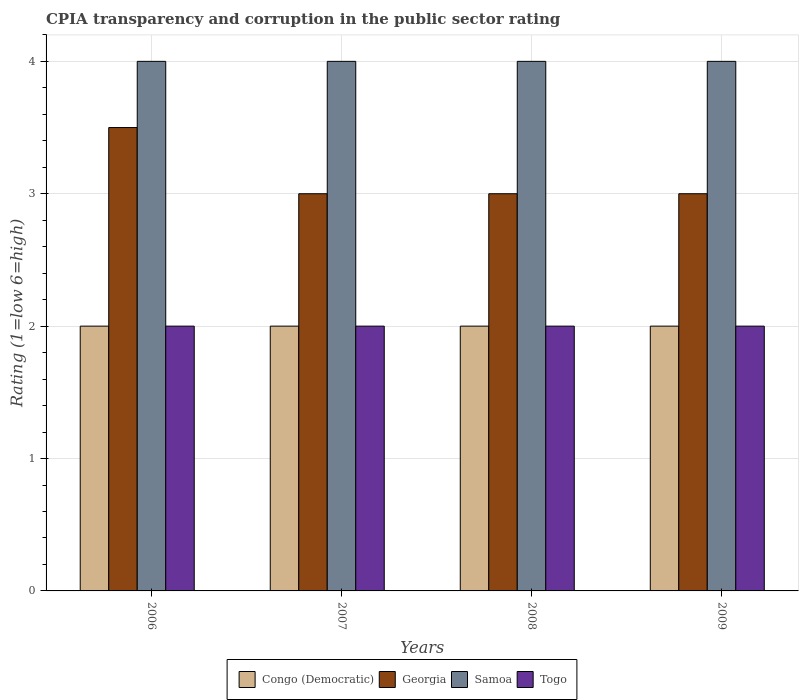How many different coloured bars are there?
Offer a terse response. 4. How many groups of bars are there?
Keep it short and to the point. 4. How many bars are there on the 1st tick from the right?
Your answer should be very brief. 4. What is the label of the 3rd group of bars from the left?
Make the answer very short. 2008. What is the CPIA rating in Congo (Democratic) in 2009?
Your response must be concise. 2. Across all years, what is the maximum CPIA rating in Georgia?
Give a very brief answer. 3.5. Across all years, what is the minimum CPIA rating in Togo?
Keep it short and to the point. 2. In the year 2006, what is the difference between the CPIA rating in Congo (Democratic) and CPIA rating in Samoa?
Give a very brief answer. -2. In how many years, is the CPIA rating in Georgia greater than 0.6000000000000001?
Your answer should be very brief. 4. What is the difference between the highest and the second highest CPIA rating in Congo (Democratic)?
Make the answer very short. 0. Is it the case that in every year, the sum of the CPIA rating in Samoa and CPIA rating in Georgia is greater than the sum of CPIA rating in Togo and CPIA rating in Congo (Democratic)?
Keep it short and to the point. No. What does the 3rd bar from the left in 2007 represents?
Give a very brief answer. Samoa. What does the 1st bar from the right in 2007 represents?
Offer a very short reply. Togo. How many bars are there?
Make the answer very short. 16. Are all the bars in the graph horizontal?
Your answer should be very brief. No. What is the difference between two consecutive major ticks on the Y-axis?
Provide a succinct answer. 1. Does the graph contain any zero values?
Give a very brief answer. No. Where does the legend appear in the graph?
Keep it short and to the point. Bottom center. How are the legend labels stacked?
Make the answer very short. Horizontal. What is the title of the graph?
Keep it short and to the point. CPIA transparency and corruption in the public sector rating. Does "Cameroon" appear as one of the legend labels in the graph?
Give a very brief answer. No. What is the label or title of the X-axis?
Give a very brief answer. Years. What is the Rating (1=low 6=high) of Congo (Democratic) in 2006?
Your answer should be compact. 2. What is the Rating (1=low 6=high) of Georgia in 2006?
Offer a terse response. 3.5. What is the Rating (1=low 6=high) in Samoa in 2006?
Provide a short and direct response. 4. What is the Rating (1=low 6=high) of Togo in 2006?
Provide a succinct answer. 2. What is the Rating (1=low 6=high) of Congo (Democratic) in 2007?
Your response must be concise. 2. What is the Rating (1=low 6=high) of Samoa in 2007?
Give a very brief answer. 4. What is the Rating (1=low 6=high) in Samoa in 2008?
Provide a succinct answer. 4. What is the Rating (1=low 6=high) of Georgia in 2009?
Keep it short and to the point. 3. What is the Rating (1=low 6=high) of Samoa in 2009?
Your answer should be very brief. 4. What is the Rating (1=low 6=high) of Togo in 2009?
Give a very brief answer. 2. Across all years, what is the maximum Rating (1=low 6=high) in Congo (Democratic)?
Your response must be concise. 2. Across all years, what is the maximum Rating (1=low 6=high) in Togo?
Offer a very short reply. 2. Across all years, what is the minimum Rating (1=low 6=high) of Congo (Democratic)?
Offer a terse response. 2. What is the total Rating (1=low 6=high) of Congo (Democratic) in the graph?
Give a very brief answer. 8. What is the total Rating (1=low 6=high) of Samoa in the graph?
Ensure brevity in your answer.  16. What is the difference between the Rating (1=low 6=high) of Congo (Democratic) in 2006 and that in 2007?
Your answer should be compact. 0. What is the difference between the Rating (1=low 6=high) in Congo (Democratic) in 2006 and that in 2008?
Ensure brevity in your answer.  0. What is the difference between the Rating (1=low 6=high) of Georgia in 2006 and that in 2008?
Make the answer very short. 0.5. What is the difference between the Rating (1=low 6=high) of Samoa in 2006 and that in 2008?
Keep it short and to the point. 0. What is the difference between the Rating (1=low 6=high) in Togo in 2006 and that in 2008?
Give a very brief answer. 0. What is the difference between the Rating (1=low 6=high) of Congo (Democratic) in 2007 and that in 2008?
Offer a terse response. 0. What is the difference between the Rating (1=low 6=high) in Samoa in 2007 and that in 2008?
Your response must be concise. 0. What is the difference between the Rating (1=low 6=high) in Togo in 2007 and that in 2008?
Your response must be concise. 0. What is the difference between the Rating (1=low 6=high) of Congo (Democratic) in 2007 and that in 2009?
Keep it short and to the point. 0. What is the difference between the Rating (1=low 6=high) of Georgia in 2008 and that in 2009?
Your answer should be compact. 0. What is the difference between the Rating (1=low 6=high) in Samoa in 2008 and that in 2009?
Offer a terse response. 0. What is the difference between the Rating (1=low 6=high) of Togo in 2008 and that in 2009?
Keep it short and to the point. 0. What is the difference between the Rating (1=low 6=high) of Samoa in 2006 and the Rating (1=low 6=high) of Togo in 2008?
Your response must be concise. 2. What is the difference between the Rating (1=low 6=high) in Congo (Democratic) in 2006 and the Rating (1=low 6=high) in Samoa in 2009?
Give a very brief answer. -2. What is the difference between the Rating (1=low 6=high) of Georgia in 2006 and the Rating (1=low 6=high) of Samoa in 2009?
Ensure brevity in your answer.  -0.5. What is the difference between the Rating (1=low 6=high) of Georgia in 2006 and the Rating (1=low 6=high) of Togo in 2009?
Provide a short and direct response. 1.5. What is the difference between the Rating (1=low 6=high) in Samoa in 2006 and the Rating (1=low 6=high) in Togo in 2009?
Provide a succinct answer. 2. What is the difference between the Rating (1=low 6=high) in Congo (Democratic) in 2007 and the Rating (1=low 6=high) in Togo in 2008?
Provide a succinct answer. 0. What is the difference between the Rating (1=low 6=high) in Congo (Democratic) in 2007 and the Rating (1=low 6=high) in Samoa in 2009?
Keep it short and to the point. -2. What is the difference between the Rating (1=low 6=high) in Congo (Democratic) in 2007 and the Rating (1=low 6=high) in Togo in 2009?
Offer a terse response. 0. What is the difference between the Rating (1=low 6=high) of Georgia in 2007 and the Rating (1=low 6=high) of Samoa in 2009?
Offer a terse response. -1. What is the difference between the Rating (1=low 6=high) in Samoa in 2007 and the Rating (1=low 6=high) in Togo in 2009?
Offer a terse response. 2. What is the difference between the Rating (1=low 6=high) of Congo (Democratic) in 2008 and the Rating (1=low 6=high) of Togo in 2009?
Offer a terse response. 0. What is the difference between the Rating (1=low 6=high) in Georgia in 2008 and the Rating (1=low 6=high) in Samoa in 2009?
Make the answer very short. -1. What is the average Rating (1=low 6=high) in Georgia per year?
Keep it short and to the point. 3.12. In the year 2006, what is the difference between the Rating (1=low 6=high) in Congo (Democratic) and Rating (1=low 6=high) in Georgia?
Provide a succinct answer. -1.5. In the year 2006, what is the difference between the Rating (1=low 6=high) of Congo (Democratic) and Rating (1=low 6=high) of Togo?
Your answer should be compact. 0. In the year 2006, what is the difference between the Rating (1=low 6=high) in Georgia and Rating (1=low 6=high) in Samoa?
Provide a short and direct response. -0.5. In the year 2006, what is the difference between the Rating (1=low 6=high) in Georgia and Rating (1=low 6=high) in Togo?
Provide a succinct answer. 1.5. In the year 2006, what is the difference between the Rating (1=low 6=high) of Samoa and Rating (1=low 6=high) of Togo?
Offer a terse response. 2. In the year 2007, what is the difference between the Rating (1=low 6=high) of Congo (Democratic) and Rating (1=low 6=high) of Georgia?
Your answer should be compact. -1. In the year 2007, what is the difference between the Rating (1=low 6=high) in Congo (Democratic) and Rating (1=low 6=high) in Samoa?
Ensure brevity in your answer.  -2. In the year 2007, what is the difference between the Rating (1=low 6=high) of Congo (Democratic) and Rating (1=low 6=high) of Togo?
Your answer should be very brief. 0. In the year 2007, what is the difference between the Rating (1=low 6=high) of Georgia and Rating (1=low 6=high) of Samoa?
Offer a very short reply. -1. In the year 2007, what is the difference between the Rating (1=low 6=high) of Samoa and Rating (1=low 6=high) of Togo?
Keep it short and to the point. 2. In the year 2008, what is the difference between the Rating (1=low 6=high) of Congo (Democratic) and Rating (1=low 6=high) of Samoa?
Your answer should be very brief. -2. In the year 2008, what is the difference between the Rating (1=low 6=high) of Congo (Democratic) and Rating (1=low 6=high) of Togo?
Make the answer very short. 0. In the year 2008, what is the difference between the Rating (1=low 6=high) of Georgia and Rating (1=low 6=high) of Samoa?
Offer a terse response. -1. In the year 2008, what is the difference between the Rating (1=low 6=high) of Georgia and Rating (1=low 6=high) of Togo?
Your answer should be compact. 1. In the year 2008, what is the difference between the Rating (1=low 6=high) of Samoa and Rating (1=low 6=high) of Togo?
Your answer should be very brief. 2. In the year 2009, what is the difference between the Rating (1=low 6=high) in Congo (Democratic) and Rating (1=low 6=high) in Samoa?
Provide a short and direct response. -2. In the year 2009, what is the difference between the Rating (1=low 6=high) of Congo (Democratic) and Rating (1=low 6=high) of Togo?
Your answer should be compact. 0. In the year 2009, what is the difference between the Rating (1=low 6=high) in Georgia and Rating (1=low 6=high) in Samoa?
Provide a succinct answer. -1. What is the ratio of the Rating (1=low 6=high) in Congo (Democratic) in 2006 to that in 2007?
Provide a succinct answer. 1. What is the ratio of the Rating (1=low 6=high) in Georgia in 2006 to that in 2007?
Offer a terse response. 1.17. What is the ratio of the Rating (1=low 6=high) in Samoa in 2006 to that in 2007?
Provide a succinct answer. 1. What is the ratio of the Rating (1=low 6=high) of Togo in 2006 to that in 2007?
Provide a short and direct response. 1. What is the ratio of the Rating (1=low 6=high) in Congo (Democratic) in 2006 to that in 2008?
Make the answer very short. 1. What is the ratio of the Rating (1=low 6=high) of Togo in 2006 to that in 2008?
Provide a short and direct response. 1. What is the ratio of the Rating (1=low 6=high) of Congo (Democratic) in 2006 to that in 2009?
Provide a succinct answer. 1. What is the ratio of the Rating (1=low 6=high) of Georgia in 2006 to that in 2009?
Offer a very short reply. 1.17. What is the ratio of the Rating (1=low 6=high) in Togo in 2006 to that in 2009?
Offer a terse response. 1. What is the ratio of the Rating (1=low 6=high) of Georgia in 2007 to that in 2008?
Offer a very short reply. 1. What is the ratio of the Rating (1=low 6=high) of Congo (Democratic) in 2007 to that in 2009?
Give a very brief answer. 1. What is the ratio of the Rating (1=low 6=high) in Georgia in 2007 to that in 2009?
Give a very brief answer. 1. What is the ratio of the Rating (1=low 6=high) in Togo in 2007 to that in 2009?
Your response must be concise. 1. What is the ratio of the Rating (1=low 6=high) in Georgia in 2008 to that in 2009?
Offer a very short reply. 1. What is the ratio of the Rating (1=low 6=high) of Samoa in 2008 to that in 2009?
Ensure brevity in your answer.  1. What is the difference between the highest and the second highest Rating (1=low 6=high) of Congo (Democratic)?
Give a very brief answer. 0. What is the difference between the highest and the second highest Rating (1=low 6=high) in Samoa?
Keep it short and to the point. 0. What is the difference between the highest and the second highest Rating (1=low 6=high) of Togo?
Ensure brevity in your answer.  0. What is the difference between the highest and the lowest Rating (1=low 6=high) in Samoa?
Make the answer very short. 0. 